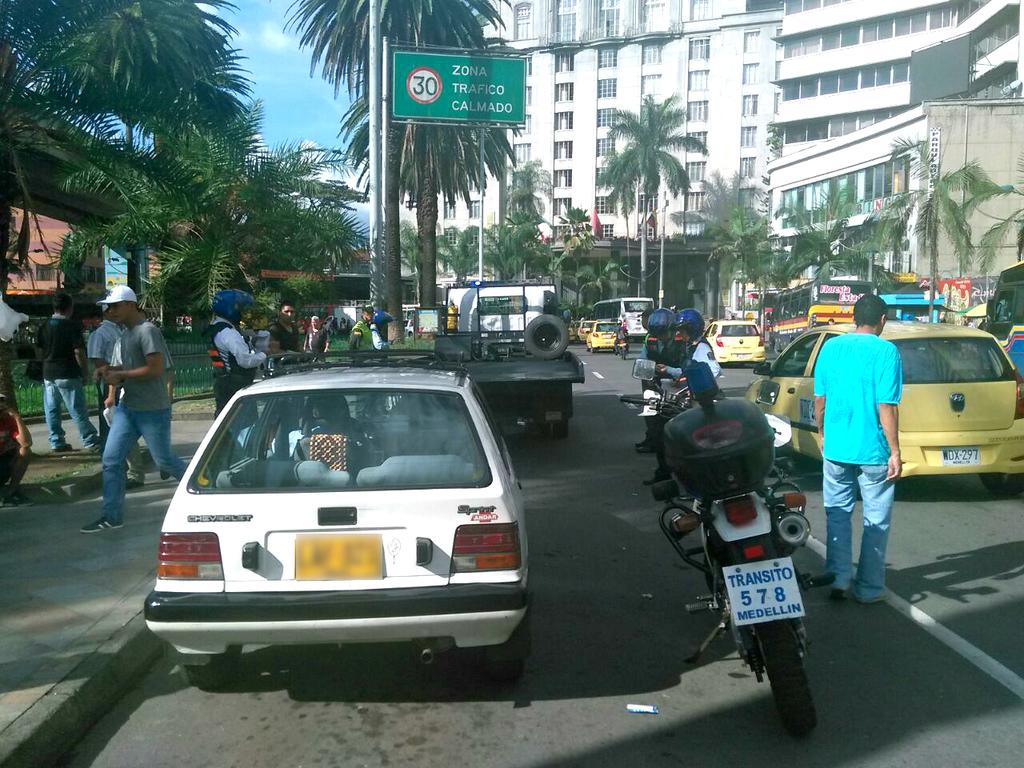<image>
Write a terse but informative summary of the picture. A motorcycle is parked in traffic and there is a sign that says 30 Zona Trafico Calmado. 